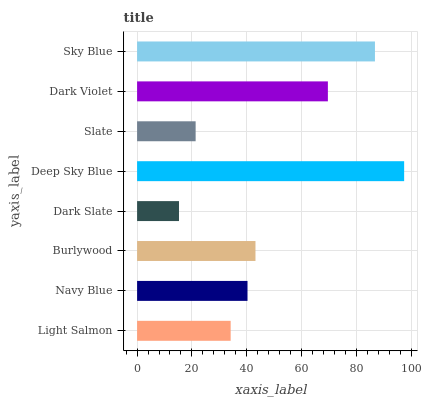Is Dark Slate the minimum?
Answer yes or no. Yes. Is Deep Sky Blue the maximum?
Answer yes or no. Yes. Is Navy Blue the minimum?
Answer yes or no. No. Is Navy Blue the maximum?
Answer yes or no. No. Is Navy Blue greater than Light Salmon?
Answer yes or no. Yes. Is Light Salmon less than Navy Blue?
Answer yes or no. Yes. Is Light Salmon greater than Navy Blue?
Answer yes or no. No. Is Navy Blue less than Light Salmon?
Answer yes or no. No. Is Burlywood the high median?
Answer yes or no. Yes. Is Navy Blue the low median?
Answer yes or no. Yes. Is Navy Blue the high median?
Answer yes or no. No. Is Slate the low median?
Answer yes or no. No. 